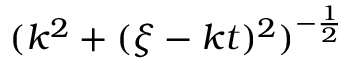<formula> <loc_0><loc_0><loc_500><loc_500>( k ^ { 2 } + ( \xi - k t ) ^ { 2 } ) ^ { - \frac { 1 } { 2 } }</formula> 